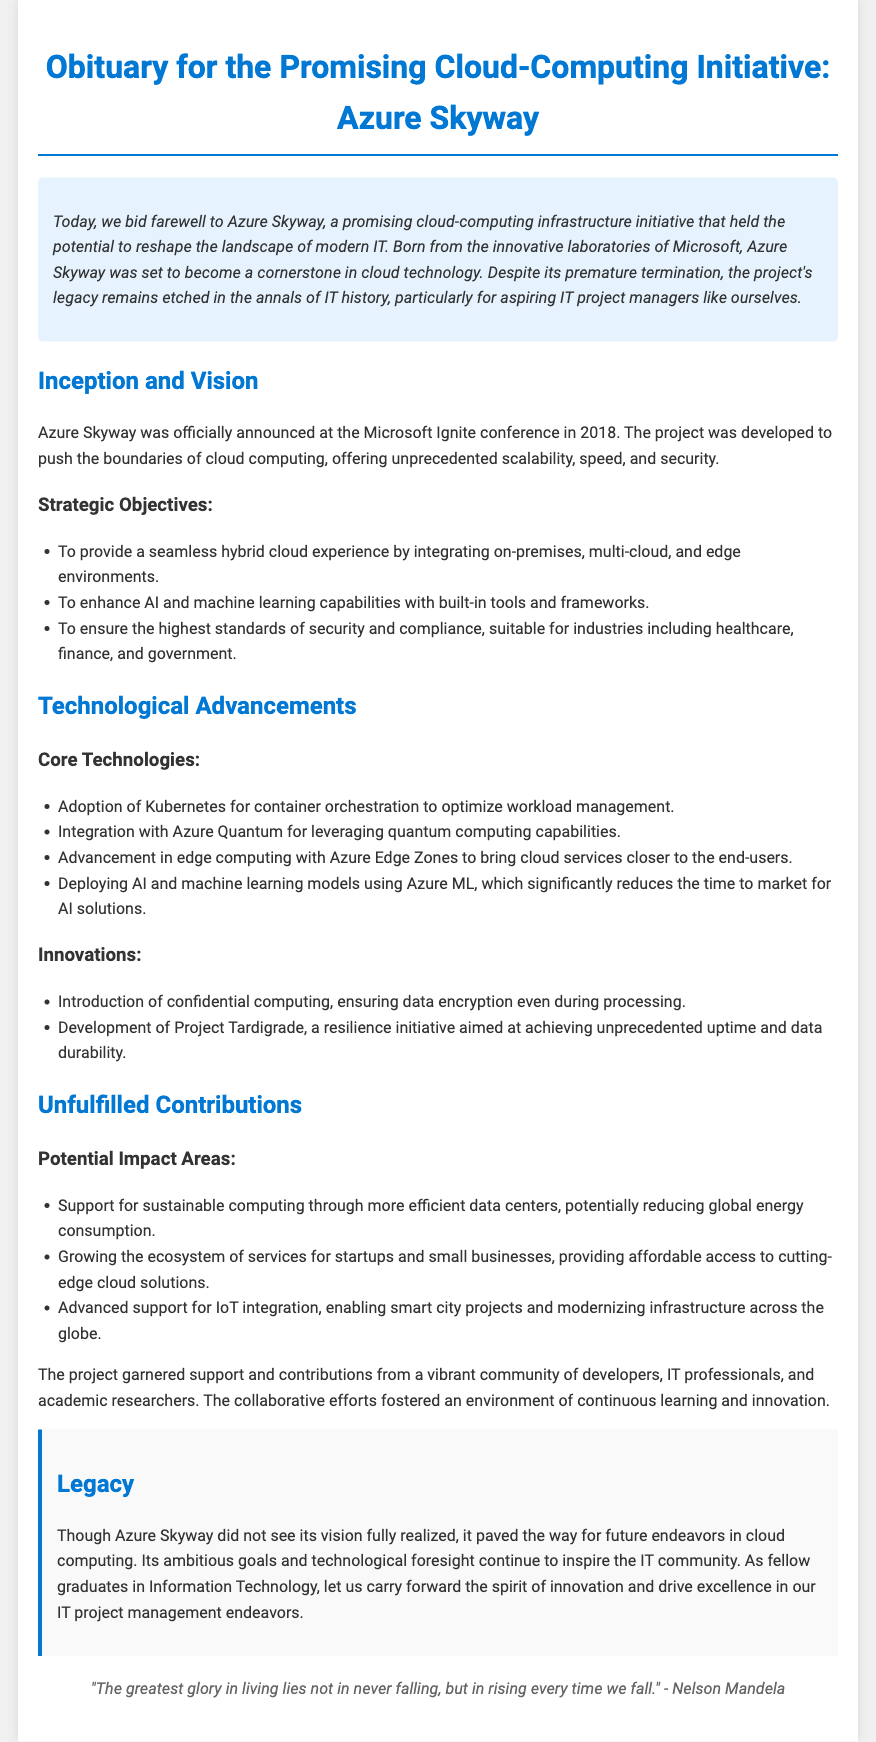what was the official announcement year of Azure Skyway? The document states that Azure Skyway was officially announced in 2018 at the Microsoft Ignite conference.
Answer: 2018 what were the strategic objectives of Azure Skyway? The strategic objectives of Azure Skyway include providing a seamless hybrid cloud experience, enhancing AI and machine learning capabilities, and ensuring high standards of security and compliance.
Answer: Seamless hybrid cloud experience, AI and machine learning, high standards of security and compliance which core technology was used for container orchestration? The document mentions that Azure Skyway adopted Kubernetes for container orchestration to optimize workload management.
Answer: Kubernetes what was one of the innovations introduced by Azure Skyway? The document lists several innovations, including confidential computing, which ensures data encryption during processing.
Answer: Confidential computing how did Azure Skyway contribute to sustainable computing? The document notes that one of the potential impact areas was supporting sustainable computing through more efficient data centers.
Answer: More efficient data centers what is the legacy of Azure Skyway according to the document? The legacy section mentions that Azure Skyway paved the way for future endeavors in cloud computing and continues to inspire the IT community.
Answer: Paved the way for future endeavors how many contributions went unfulfilled according to the document? The document emphasizes multiple contributions that went unfulfilled without specifying an exact number.
Answer: Multiple who made the quote included in the document? The quote in the document is attributed to Nelson Mandela.
Answer: Nelson Mandela 